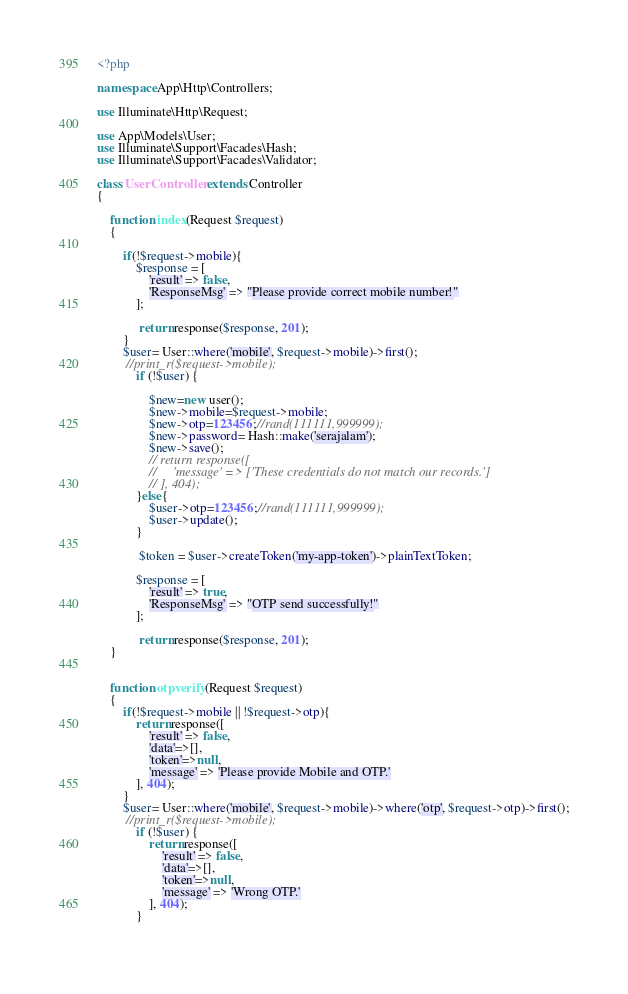<code> <loc_0><loc_0><loc_500><loc_500><_PHP_><?php

namespace App\Http\Controllers;

use Illuminate\Http\Request;

use App\Models\User;
use Illuminate\Support\Facades\Hash;
use Illuminate\Support\Facades\Validator;

class UserController extends Controller
{

    function index(Request $request)
    {
       
        if(!$request->mobile){
            $response = [
                'result' => false,
                'ResponseMsg' => "Please provide correct mobile number!"
            ];
        
             return response($response, 201);
        }
        $user= User::where('mobile', $request->mobile)->first();
         //print_r($request->mobile);
            if (!$user) {

                $new=new user();
                $new->mobile=$request->mobile;
                $new->otp=123456;//rand(111111,999999);
                $new->password= Hash::make('serajalam');
                $new->save();
                // return response([
                //     'message' => ['These credentials do not match our records.']
                // ], 404);
            }else{
                $user->otp=123456;//rand(111111,999999);
                $user->update();
            }
        
             $token = $user->createToken('my-app-token')->plainTextToken;
        
            $response = [
                'result' => true,
                'ResponseMsg' => "OTP send successfully!"
            ];
        
             return response($response, 201);
    }


    function otpverify(Request $request)
    {
        if(!$request->mobile || !$request->otp){
            return response([
                'result' => false,
                'data'=>[],
                'token'=>null,
                'message' => 'Please provide Mobile and OTP.'
            ], 404);
        }
        $user= User::where('mobile', $request->mobile)->where('otp', $request->otp)->first();
         //print_r($request->mobile);
            if (!$user) {
                return response([
                    'result' => false,
                    'data'=>[],
                    'token'=>null,
                    'message' => 'Wrong OTP.'
                ], 404);
            }
        </code> 